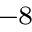<formula> <loc_0><loc_0><loc_500><loc_500>^ { - 8 }</formula> 